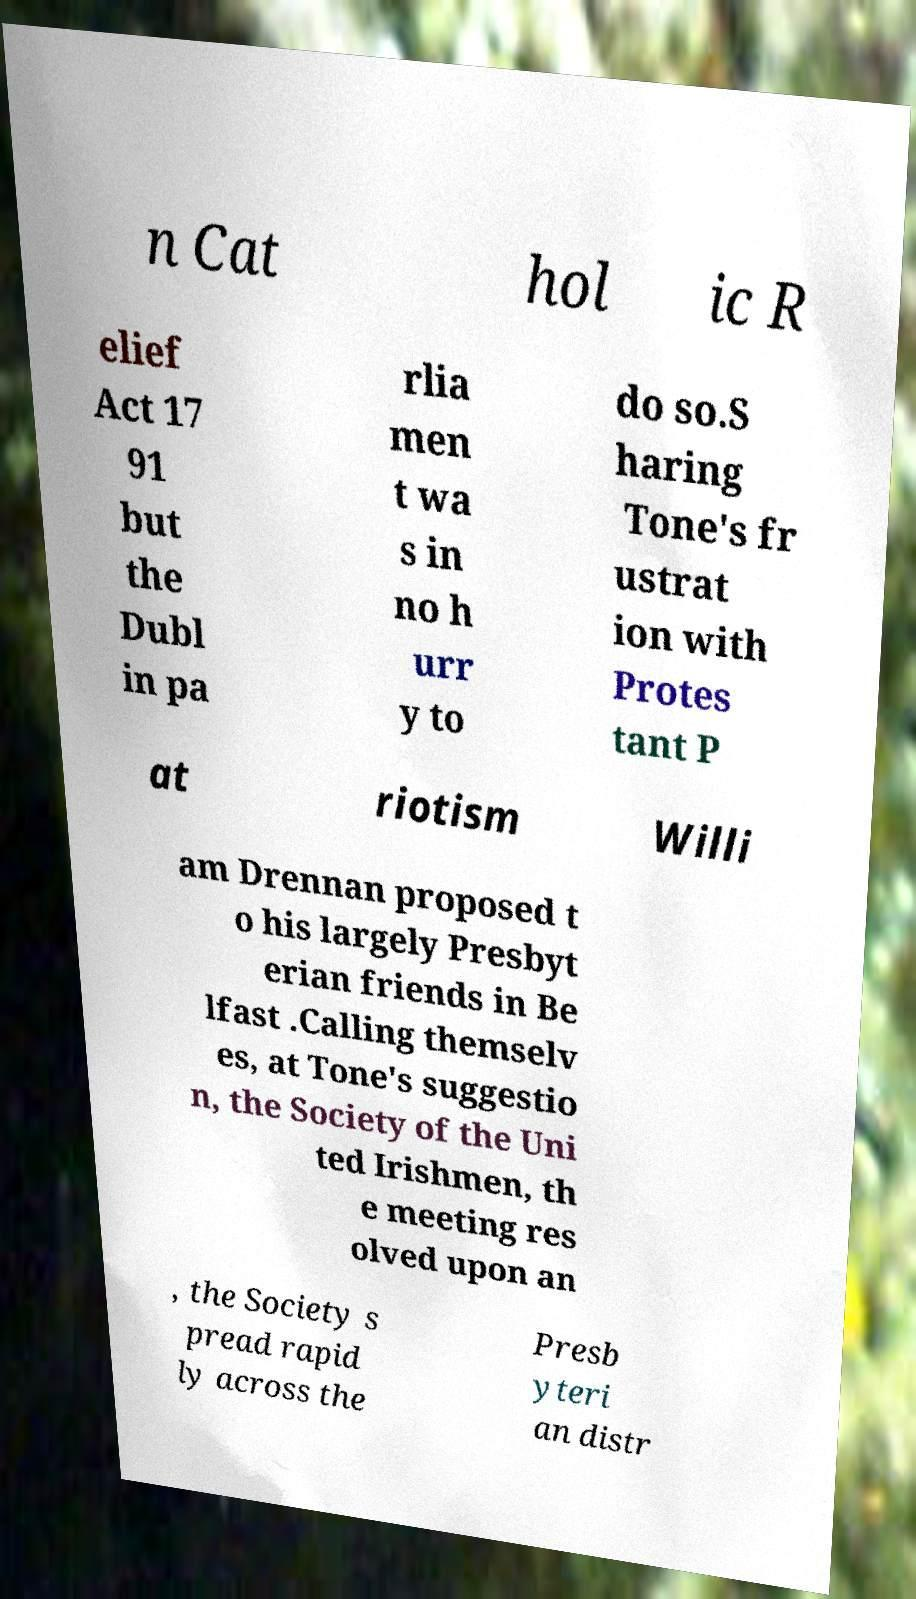I need the written content from this picture converted into text. Can you do that? n Cat hol ic R elief Act 17 91 but the Dubl in pa rlia men t wa s in no h urr y to do so.S haring Tone's fr ustrat ion with Protes tant P at riotism Willi am Drennan proposed t o his largely Presbyt erian friends in Be lfast .Calling themselv es, at Tone's suggestio n, the Society of the Uni ted Irishmen, th e meeting res olved upon an , the Society s pread rapid ly across the Presb yteri an distr 